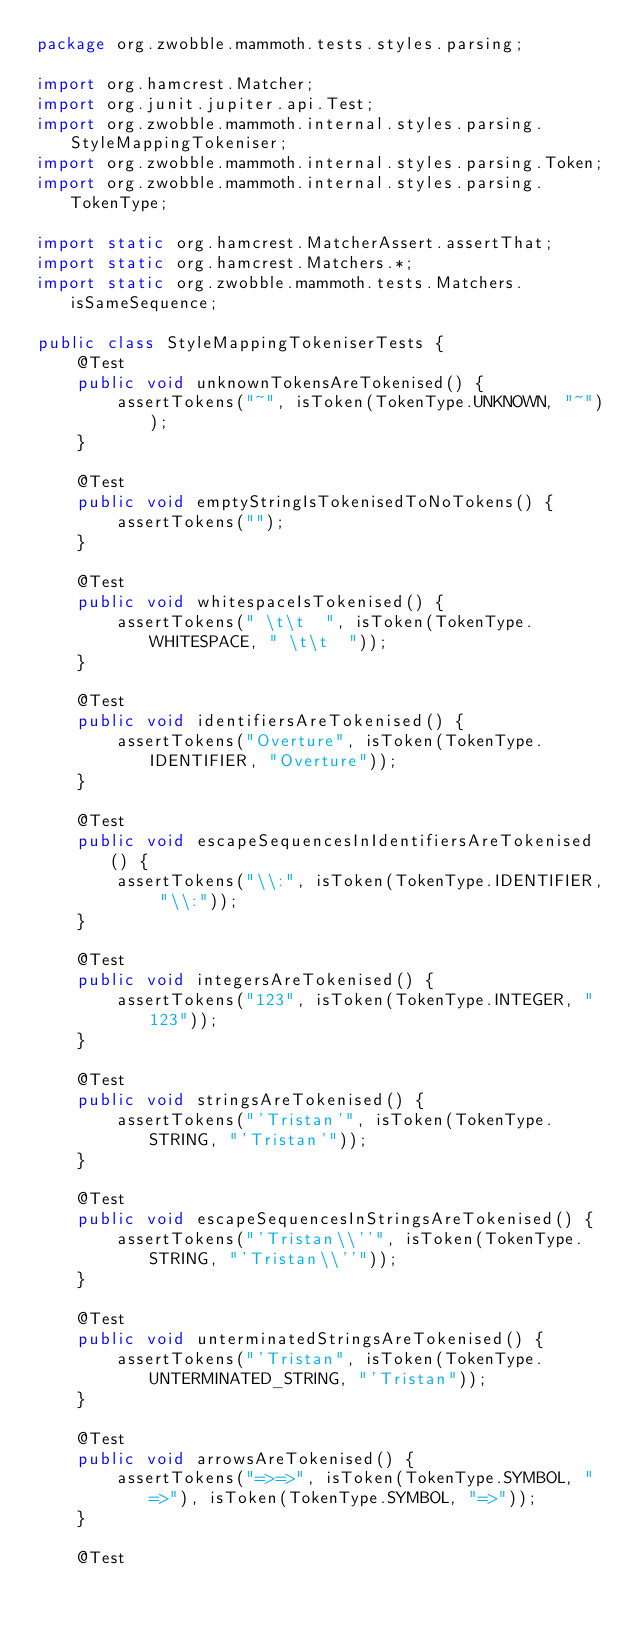Convert code to text. <code><loc_0><loc_0><loc_500><loc_500><_Java_>package org.zwobble.mammoth.tests.styles.parsing;

import org.hamcrest.Matcher;
import org.junit.jupiter.api.Test;
import org.zwobble.mammoth.internal.styles.parsing.StyleMappingTokeniser;
import org.zwobble.mammoth.internal.styles.parsing.Token;
import org.zwobble.mammoth.internal.styles.parsing.TokenType;

import static org.hamcrest.MatcherAssert.assertThat;
import static org.hamcrest.Matchers.*;
import static org.zwobble.mammoth.tests.Matchers.isSameSequence;

public class StyleMappingTokeniserTests {
    @Test
    public void unknownTokensAreTokenised() {
        assertTokens("~", isToken(TokenType.UNKNOWN, "~"));
    }

    @Test
    public void emptyStringIsTokenisedToNoTokens() {
        assertTokens("");
    }

    @Test
    public void whitespaceIsTokenised() {
        assertTokens(" \t\t  ", isToken(TokenType.WHITESPACE, " \t\t  "));
    }

    @Test
    public void identifiersAreTokenised() {
        assertTokens("Overture", isToken(TokenType.IDENTIFIER, "Overture"));
    }

    @Test
    public void escapeSequencesInIdentifiersAreTokenised() {
        assertTokens("\\:", isToken(TokenType.IDENTIFIER, "\\:"));
    }

    @Test
    public void integersAreTokenised() {
        assertTokens("123", isToken(TokenType.INTEGER, "123"));
    }

    @Test
    public void stringsAreTokenised() {
        assertTokens("'Tristan'", isToken(TokenType.STRING, "'Tristan'"));
    }

    @Test
    public void escapeSequencesInStringsAreTokenised() {
        assertTokens("'Tristan\\''", isToken(TokenType.STRING, "'Tristan\\''"));
    }

    @Test
    public void unterminatedStringsAreTokenised() {
        assertTokens("'Tristan", isToken(TokenType.UNTERMINATED_STRING, "'Tristan"));
    }

    @Test
    public void arrowsAreTokenised() {
        assertTokens("=>=>", isToken(TokenType.SYMBOL, "=>"), isToken(TokenType.SYMBOL, "=>"));
    }

    @Test</code> 